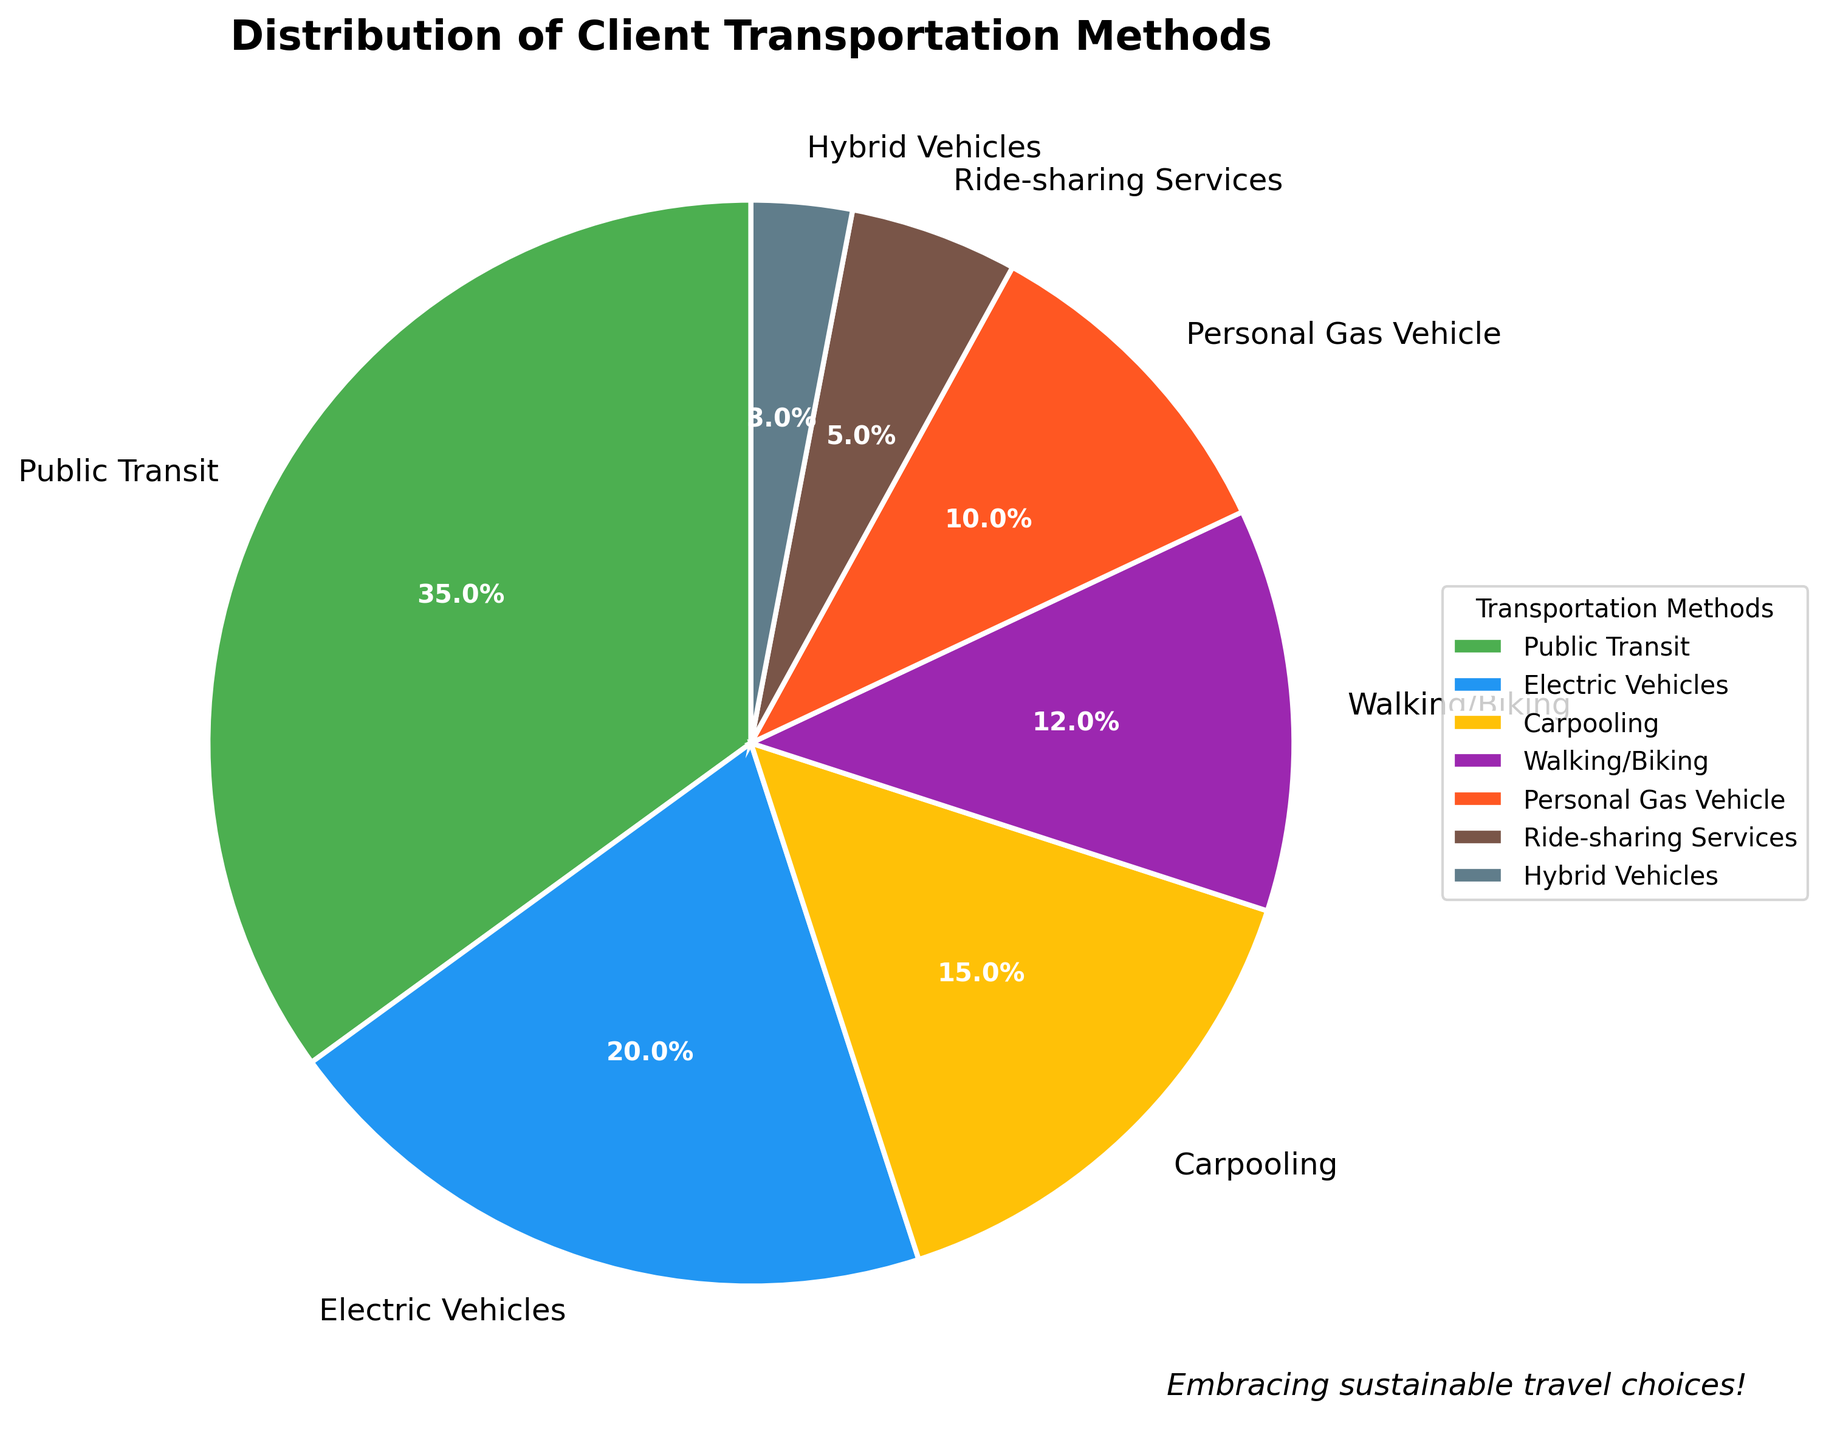What percentage of clients use public transit or electric vehicles? Sum the percentage of clients using public transit (35%) and electric vehicles (20%) which gives 35 + 20 = 55.
Answer: 55% Which transportation method has the least usage? The smallest percentage in the chart corresponds to hybrid vehicles which have a percentage of 3%.
Answer: Hybrid Vehicles Compare the usage of walking/biking to personal gas vehicles. Which is higher and by how much? Walking/Biking is 12% and Personal Gas Vehicle is 10%. The difference is 12 - 10 = 2 percentage points.
Answer: Walking/Biking by 2% What is the combined percentage of clients using green transportation methods (public transit, electric vehicles, walking/biking, carpooling, hybrid vehicles)? Sum the percentages of public transit (35%), electric vehicles (20%), walking/biking (12%), carpooling (15%), and hybrid vehicles (3%). The combined percentage is 35 + 20 + 12 + 15 + 3 = 85%.
Answer: 85% Which method has a higher percentage: ride-sharing services or carpooling? Ride-sharing services have 5%, and carpooling has 15%. Therefore, carpooling has a higher percentage.
Answer: Carpooling Are there more clients using personal gas vehicles or ride-sharing services? Personal gas vehicles are at 10%, while ride-sharing services are at 5%. Therefore, more clients are using personal gas vehicles.
Answer: Personal Gas Vehicles Which transportation method is used exactly twice as much as ride-sharing services? Ride-sharing services have 5%, so twice this amount is 10%. Personal gas vehicle has 10%, which is twice that of ride-sharing services.
Answer: Personal Gas Vehicles By how many percentage points does electric vehicle usage exceed ride-sharing services? Electric vehicles are at 20% and ride-sharing services are at 5%. The difference is 20 - 5 = 15 percentage points.
Answer: 15 What color represents the transportation method with the highest percentage in the pie chart? The transportation method with the highest percentage is public transit (35%), and the color representing it is green.
Answer: Green How does the percentage of clients using electric vehicles compare to the total percentage of clients using personal gas vehicles, ride-sharing services, and hybrid vehicles combined? The percentage of clients using electric vehicles is 20%. Sum the percentages for personal gas vehicles (10%), ride-sharing services (5%), and hybrid vehicles (3%), which is 10 + 5 + 3 = 18%. Therefore, electric vehicle usage is higher by 20 - 18 = 2 percentage points.
Answer: 2 